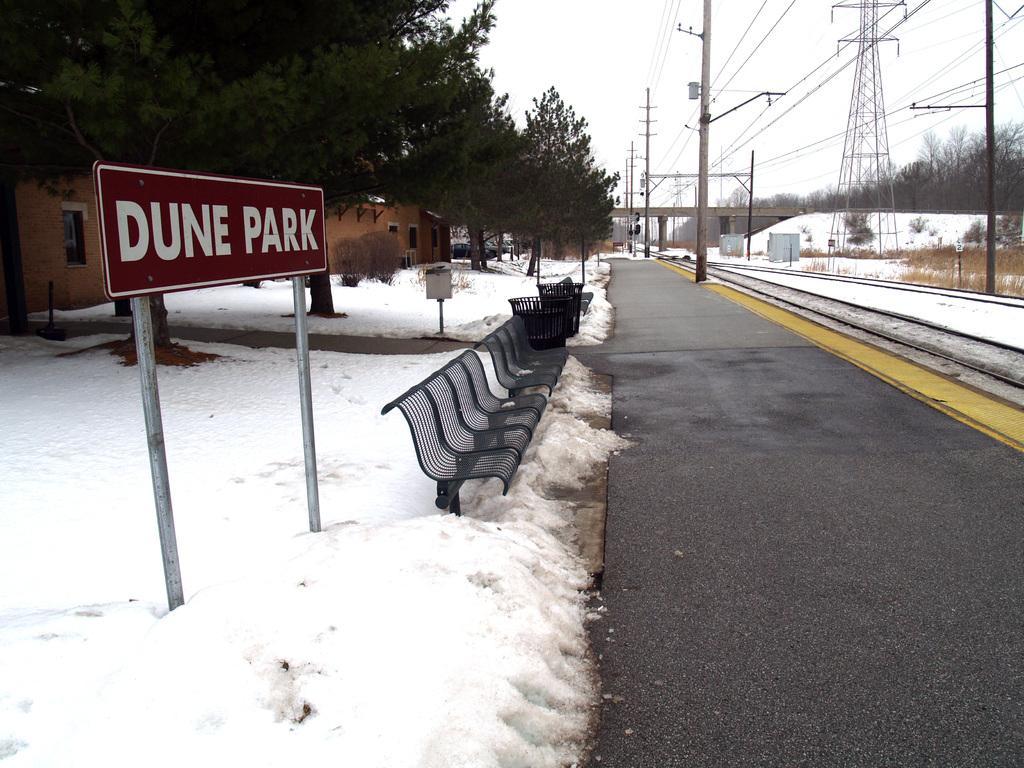In one or two sentences, can you explain what this image depicts? As we can see in the image there is snow, chairs, dustbins, trees, buildings, current poles and at the top there is sky. 